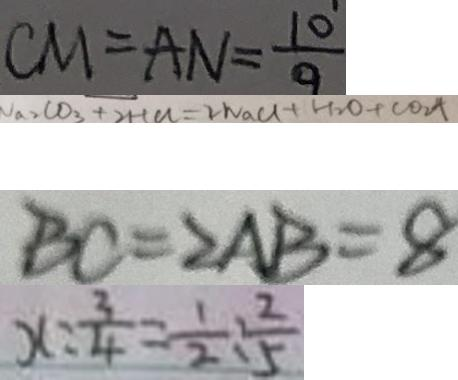<formula> <loc_0><loc_0><loc_500><loc_500>C M = A N = \frac { 1 0 } { 9 } 
 N a _ { 2 } C O _ { 3 } + 2 H C l = 2 N a C l + H _ { 2 } O + C O _ { 2 } \uparrow 
 B C = 2 A B = 8 
 x : \frac { 3 } { 4 } = \frac { 1 } { 2 } : \frac { 2 } { 5 }</formula> 